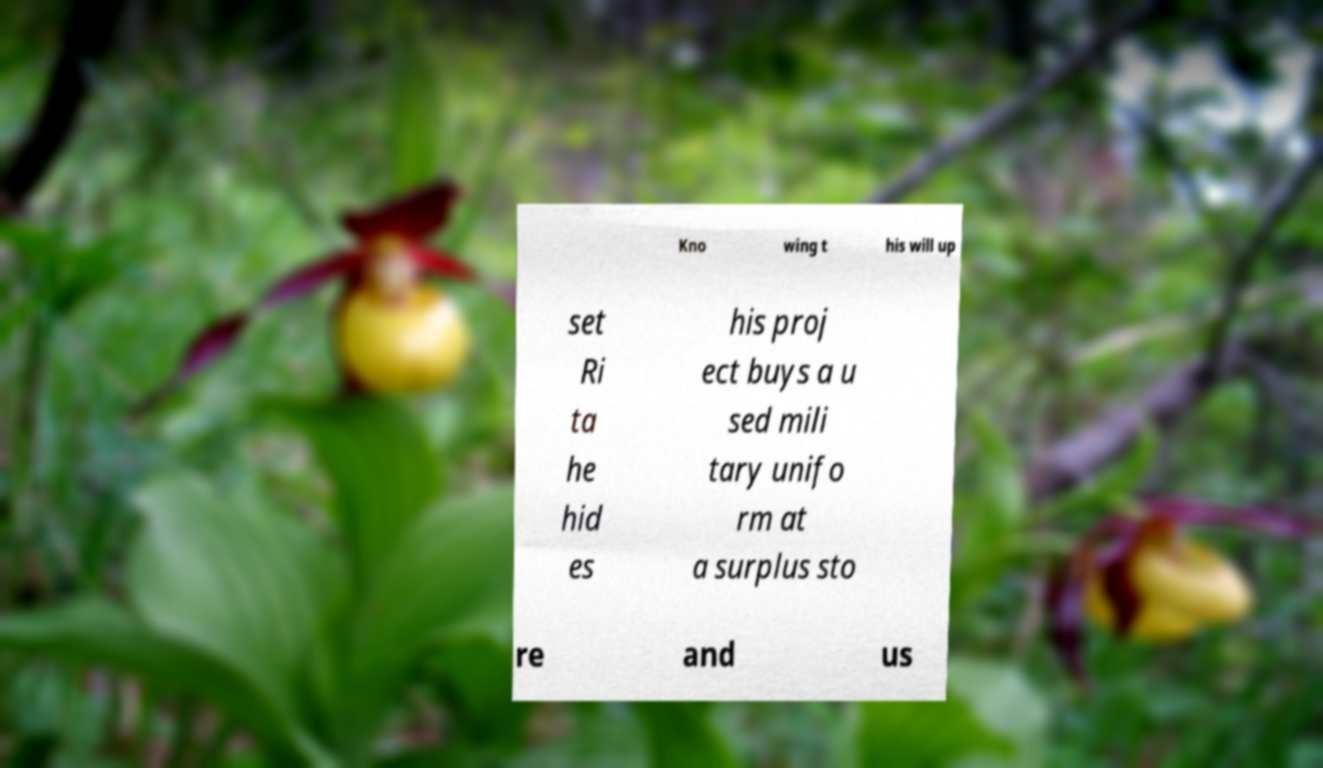Could you extract and type out the text from this image? Kno wing t his will up set Ri ta he hid es his proj ect buys a u sed mili tary unifo rm at a surplus sto re and us 